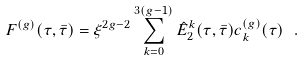<formula> <loc_0><loc_0><loc_500><loc_500>F ^ { ( g ) } ( \tau , \bar { \tau } ) = \xi ^ { 2 g - 2 } \sum _ { k = 0 } ^ { 3 ( g - 1 ) } \hat { E } _ { 2 } ^ { k } ( \tau , \bar { \tau } ) c ^ { ( g ) } _ { k } ( \tau ) \ .</formula> 